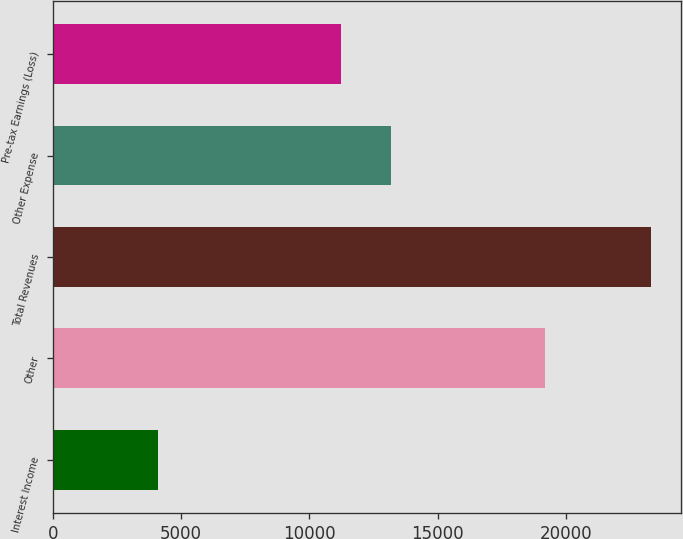Convert chart. <chart><loc_0><loc_0><loc_500><loc_500><bar_chart><fcel>Interest Income<fcel>Other<fcel>Total Revenues<fcel>Other Expense<fcel>Pre-tax Earnings (Loss)<nl><fcel>4114<fcel>19197<fcel>23311<fcel>13167.7<fcel>11248<nl></chart> 